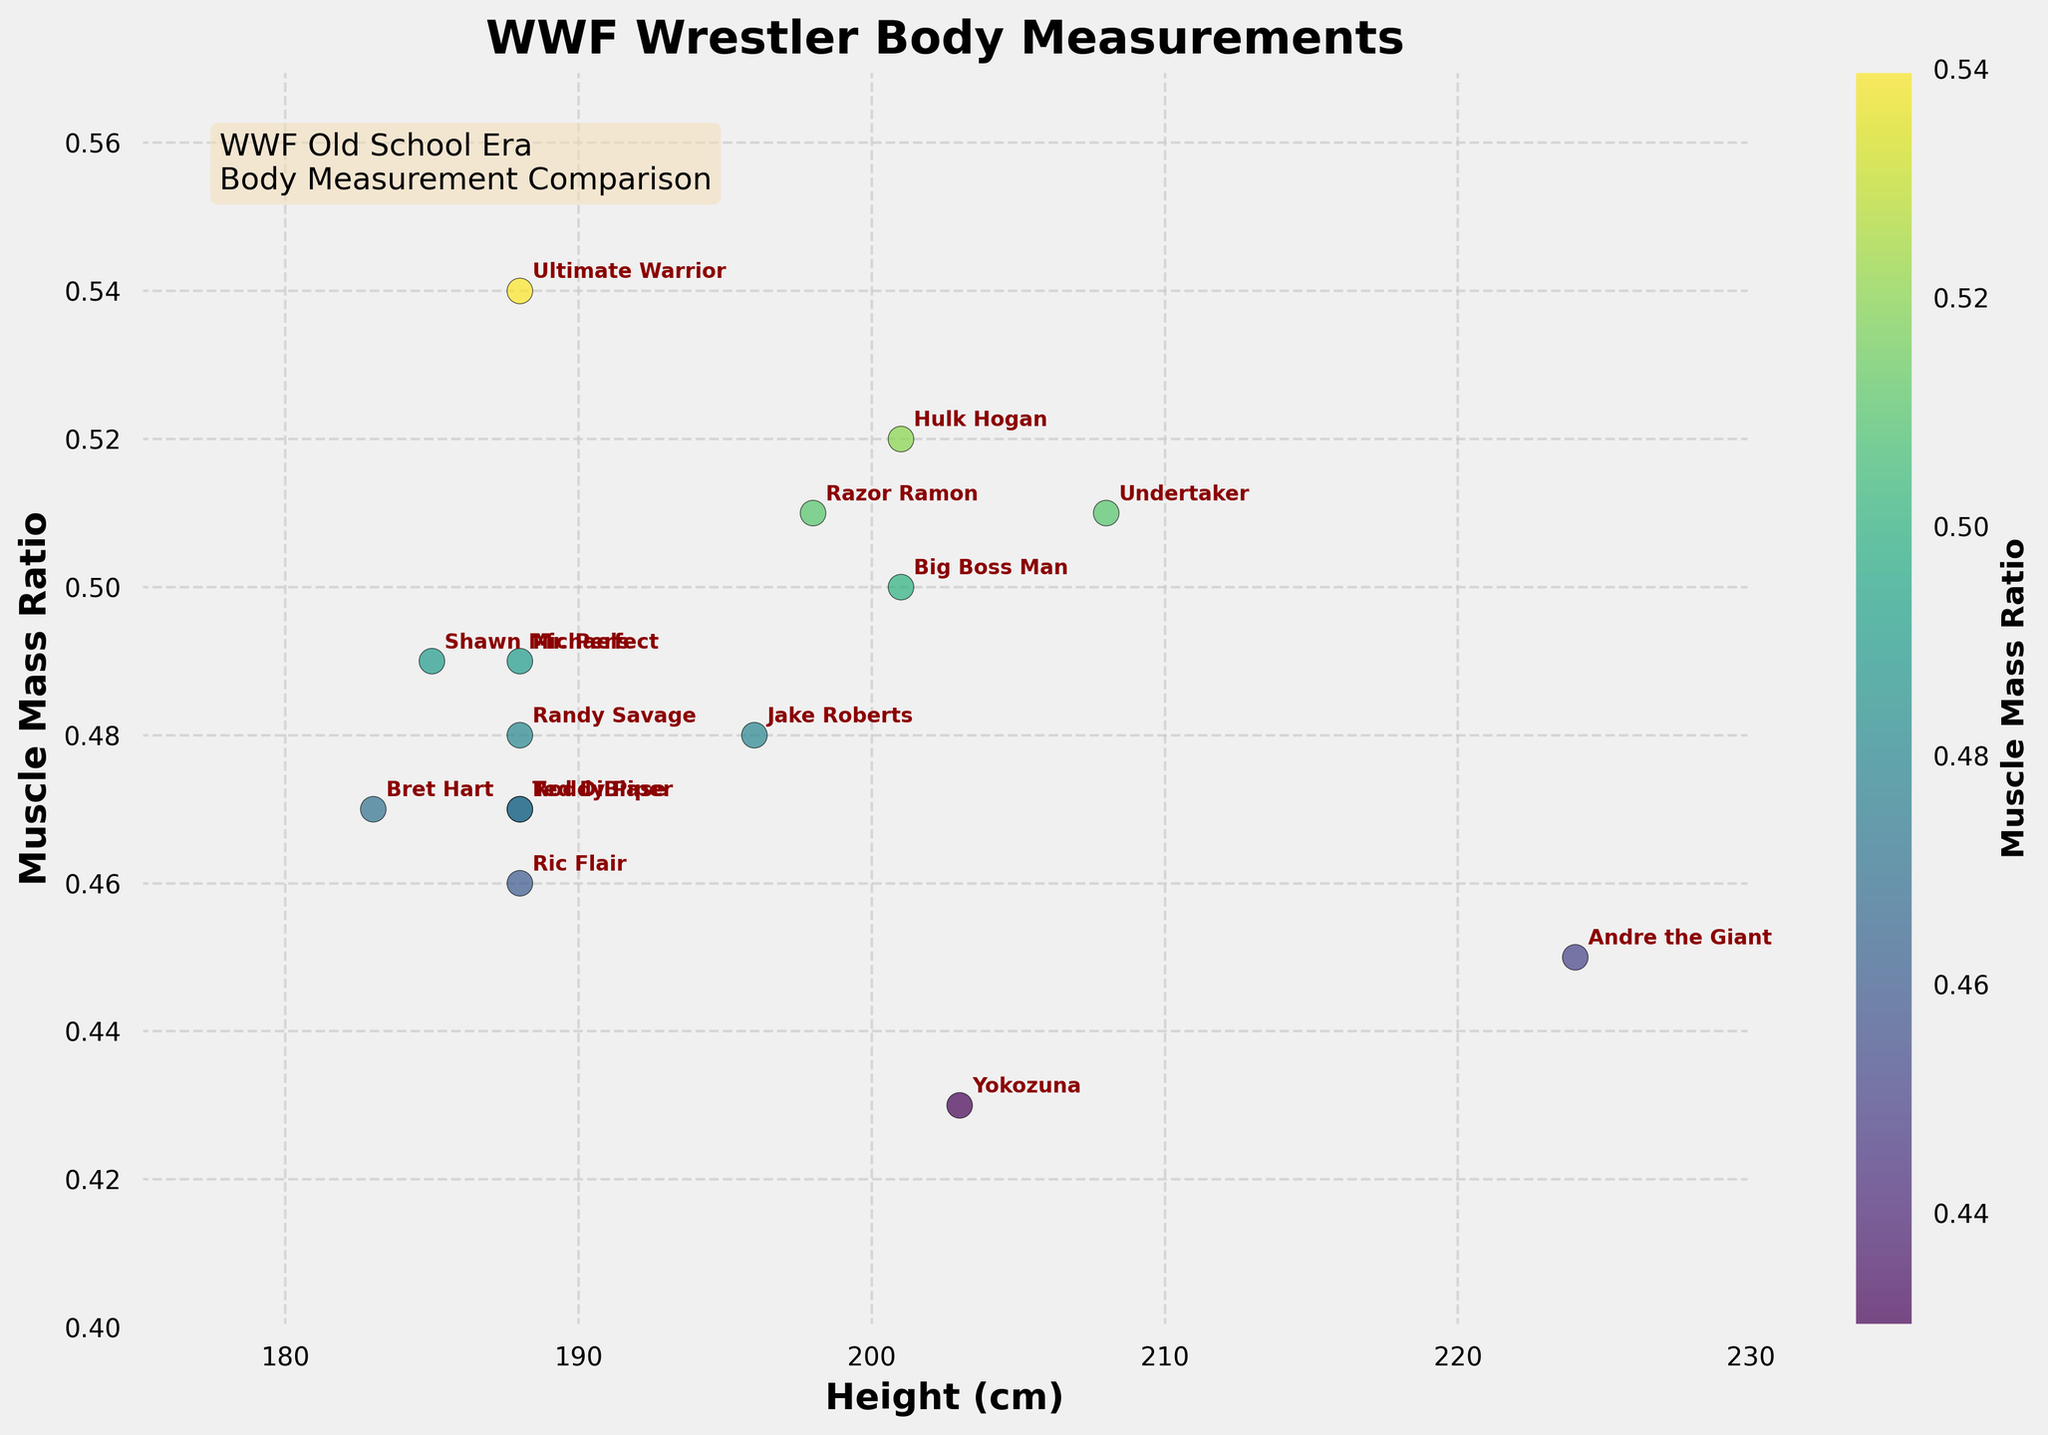What is the title of the figure? The title of the figure is provided at the top, and it typically summarizes the main topic of the plot.
Answer: WWF Wrestler Body Measurements What is the color used to plot the scatter points? The scatter points are color-coded based on their muscle mass ratios, with a gradient ranging from light to dark colors, as indicated by the colorbar on the side.
Answer: Viridis colormap (green to purple) Which wrestler has the highest muscle mass ratio? By looking at the highest point on the Y-axis, we can see which wrestler has the highest muscle mass ratio.
Answer: Ultimate Warrior How many wrestlers have a muscle mass ratio higher than 0.50? To find this, count the number of points above the 0.50 mark on the Y-axis.
Answer: Four What is the height of Hulk Hogan compared to Andre the Giant? Check the X-axis positions of Hulk Hogan and Andre the Giant to note their corresponding heights and compare them.
Answer: Hulk Hogan is shorter Which wrestler is the tallest? Identify the wrestler whose point is farthest to the right on the X-axis.
Answer: Andre the Giant What is the average muscle mass ratio of wrestlers whose height is above 200 cm? Filter wrestlers above 200 cm and compute their mean muscle mass ratio: (0.52 + 0.50 + 0.43) / 3
Answer: 0.48 Which wrestler has the closest height and muscle mass ratio to Ric Flair? Compare the height and muscle mass ratio of Ric Flair with other wrestlers to identify the closest point.
Answer: Randy Savage What is the difference in muscle mass ratio between the Undertaker and Bret Hart? Find the muscle mass ratios of Undertaker (0.51) and Bret Hart (0.47) and subtract them: 0.51 - 0.47
Answer: 0.04 Which wrestler has a similar muscle mass ratio to Shawn Michaels but is taller in height? Locate Shawn Michaels' point and find a point at a similar Y-axis level but further right on the X-axis.
Answer: Razor Ramon 